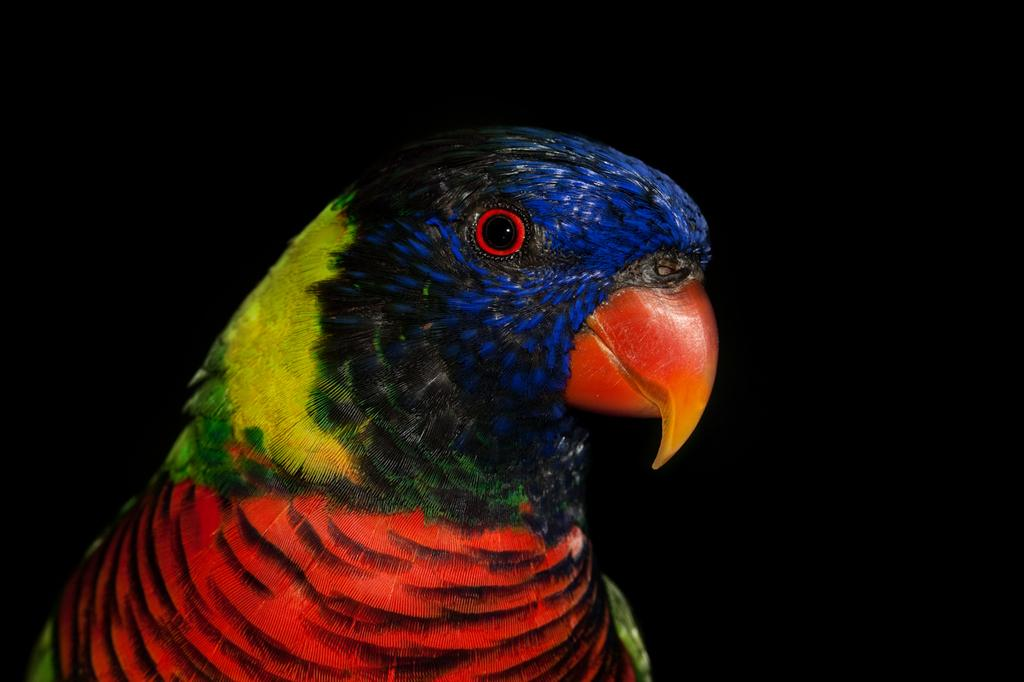What type of animal is in the picture? There is a parrot in the picture. What colors can be seen on the parrot? The parrot has red, yellow, green, black, and blue colors. What colors are present on the parrot's beak? The parrot's beak is red and yellow in color. What type of pest is the parrot's father in the image? There is no mention of a father or pest in the image; it only features a parrot with specific colors. 